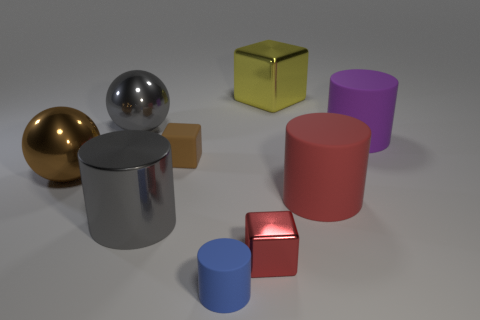What number of other objects are the same material as the brown sphere?
Make the answer very short. 4. Is the material of the gray cylinder the same as the large ball that is behind the big purple matte cylinder?
Offer a very short reply. Yes. How many objects are either large objects that are behind the large metallic cylinder or tiny things in front of the big cube?
Offer a terse response. 8. How many other objects are the same color as the large metallic cube?
Provide a succinct answer. 0. Is the number of brown spheres to the left of the big gray sphere greater than the number of rubber objects that are to the left of the metallic cylinder?
Your response must be concise. Yes. What number of cubes are tiny things or large purple rubber things?
Offer a very short reply. 2. How many things are large metal things that are in front of the big purple rubber cylinder or small blue objects?
Keep it short and to the point. 3. What shape is the brown object that is in front of the tiny object left of the small matte cylinder in front of the brown block?
Offer a very short reply. Sphere. What number of tiny red shiny objects have the same shape as the small brown thing?
Your answer should be very brief. 1. There is a large ball that is the same color as the tiny matte block; what is its material?
Offer a terse response. Metal. 